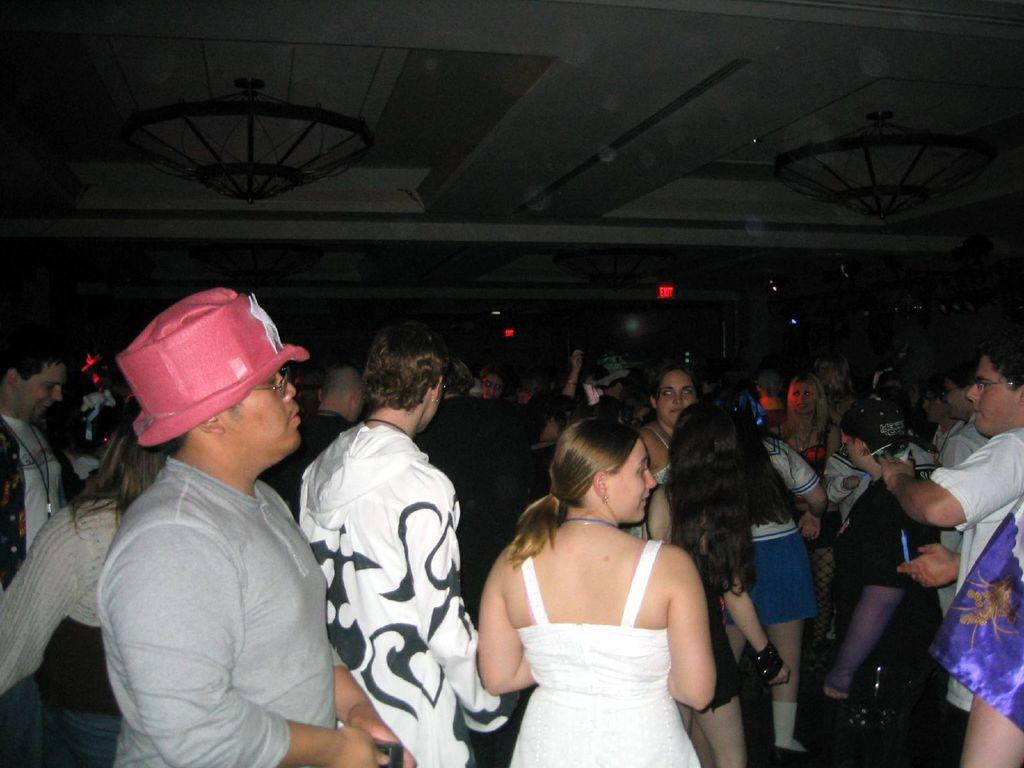What can be seen in the image involving people? There are people standing in the image. What is located in the background of the image? There is a wall in the background of the image. What type of illumination is present in the image? Lights are visible in the image. What type of decorative lighting can be seen at the top of the image? There are chandeliers at the top of the image. What type of flesh can be seen hanging from the chandeliers in the image? There is no flesh hanging from the chandeliers in the image; the chandeliers are decorative lighting fixtures. 